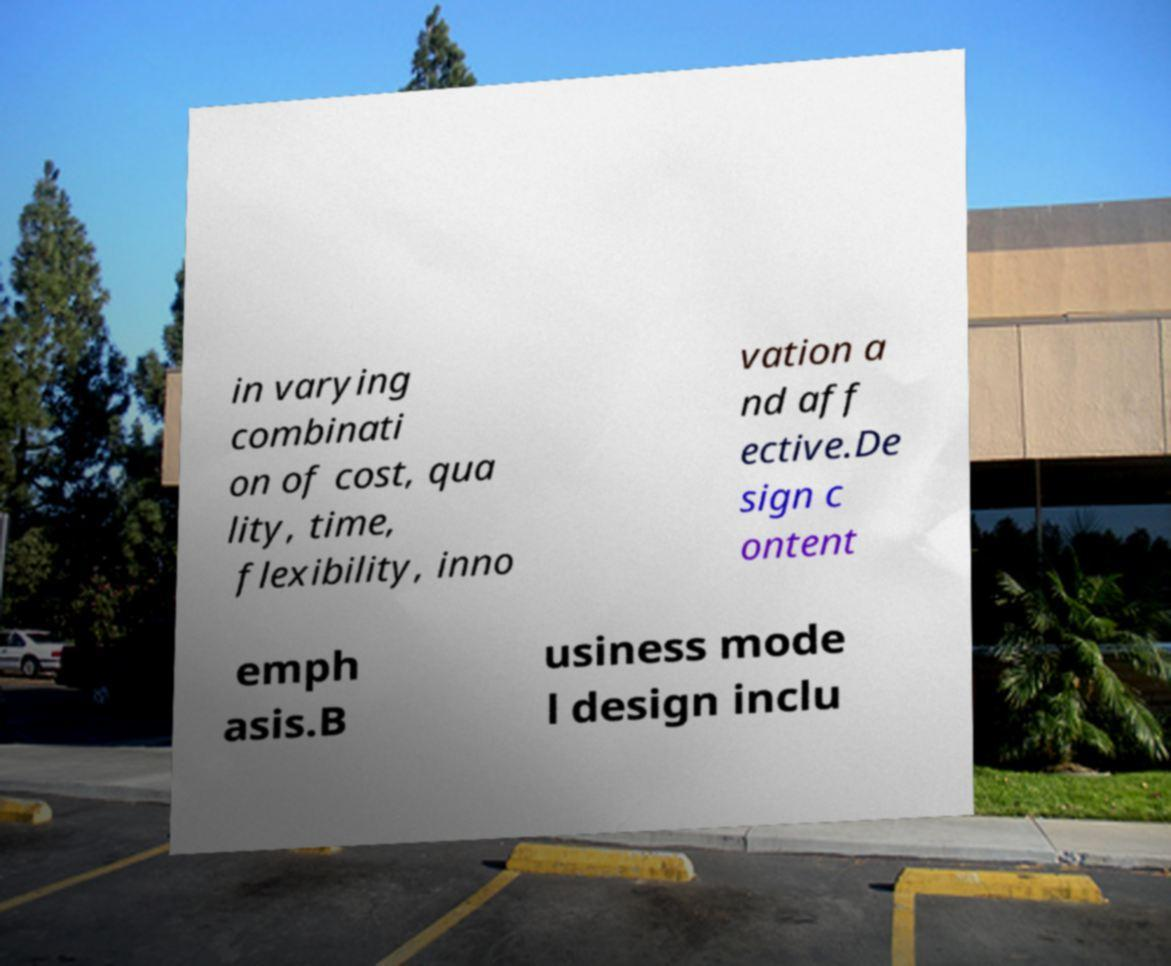I need the written content from this picture converted into text. Can you do that? in varying combinati on of cost, qua lity, time, flexibility, inno vation a nd aff ective.De sign c ontent emph asis.B usiness mode l design inclu 